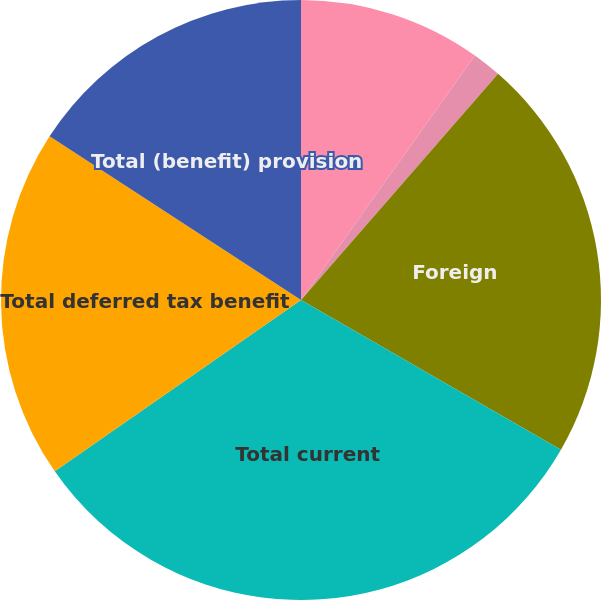Convert chart to OTSL. <chart><loc_0><loc_0><loc_500><loc_500><pie_chart><fcel>Federal<fcel>State and local<fcel>Foreign<fcel>Total current<fcel>Total deferred tax benefit<fcel>Total (benefit) provision<nl><fcel>9.84%<fcel>1.57%<fcel>21.91%<fcel>32.01%<fcel>18.86%<fcel>15.82%<nl></chart> 